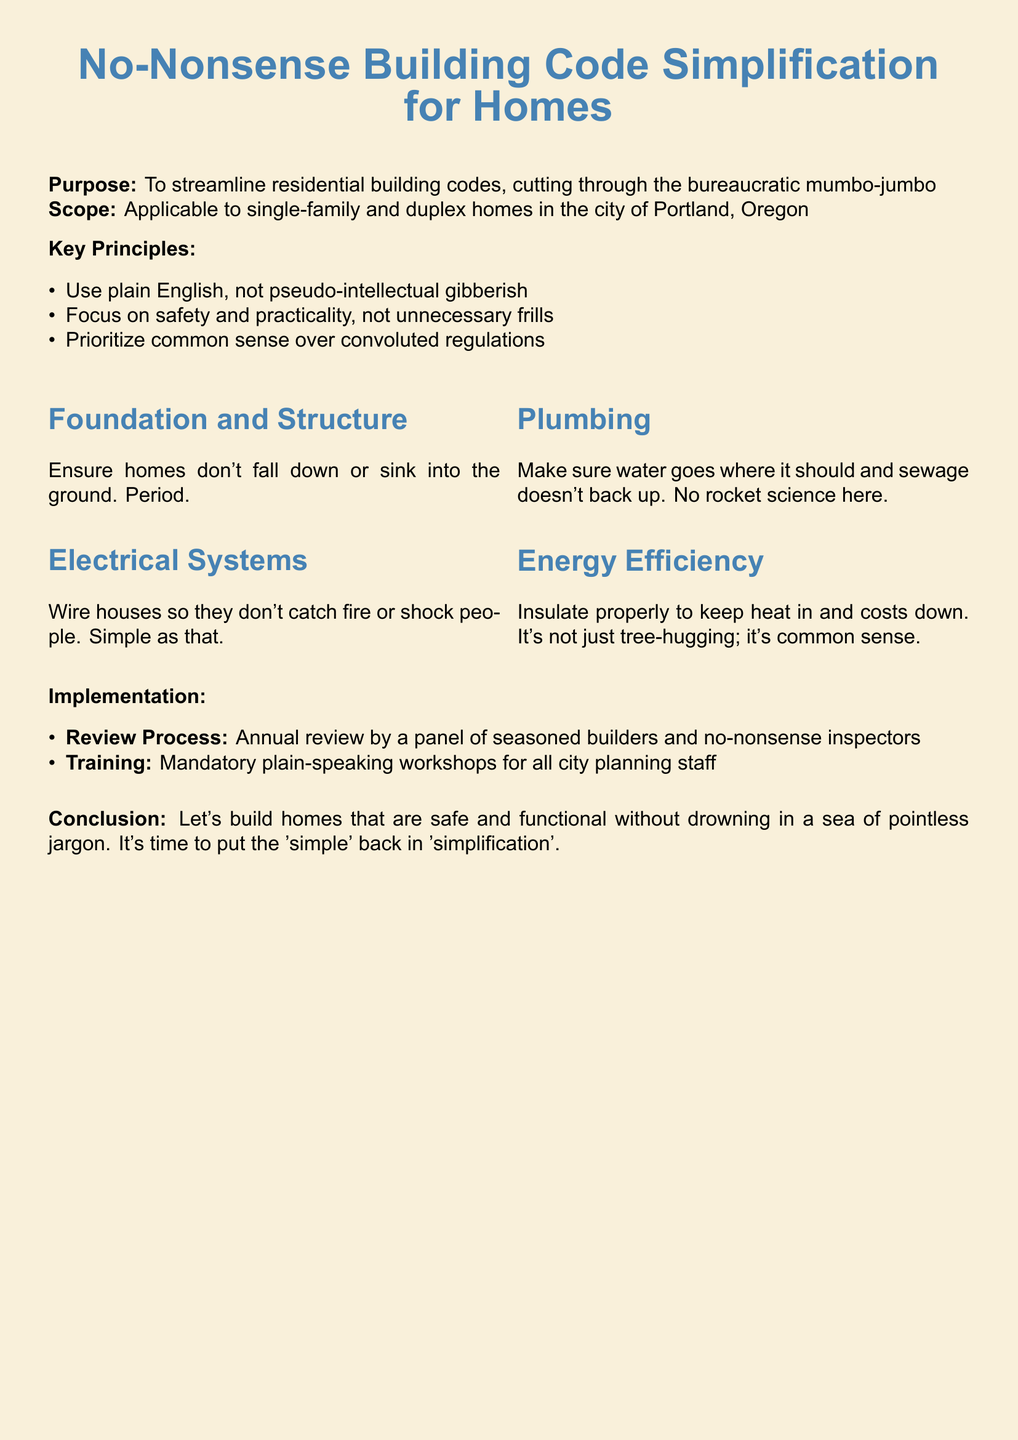What is the purpose of the document? The purpose is to streamline residential building codes and cut through bureaucratic mumbo-jumbo.
Answer: To streamline residential building codes, cutting through the bureaucratic mumbo-jumbo Who is the target audience for the policy? The target audience is specified as single-family and duplex homes in the city of Portland, Oregon.
Answer: Single-family and duplex homes in the city of Portland, Oregon What is the focus of the Key Principles section? The section emphasizes using plain English, focusing on safety and practicality, and prioritizing common sense.
Answer: Use plain English, not pseudo-intellectual gibberish What year is the review process conducted? The review process takes place annually, as mentioned in the document.
Answer: Annual What is the overall conclusion of the policy? The conclusion promotes building safe and functional homes while avoiding excessive jargon.
Answer: Let's build homes that are safe and functional without drowning in a sea of pointless jargon What is highlighted under the foundation and structure section? The section stresses that homes should not fall down or sink into the ground.
Answer: Ensure homes don't fall down or sink into the ground. Period What is the requirement for city planning staff training? The document states that there will be mandatory workshops for plain speaking.
Answer: Mandatory plain-speaking workshops for all city planning staff What is the approach taken towards energy efficiency? The policy emphasizes proper insulation to maintain heat and reduce costs.
Answer: Insulate properly to keep heat in and costs down 